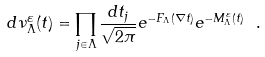Convert formula to latex. <formula><loc_0><loc_0><loc_500><loc_500>d \nu ^ { \varepsilon } _ { \Lambda } ( t ) = \prod _ { j \in \Lambda } \frac { d t _ { j } } { \sqrt { 2 \pi } } e ^ { - F _ { \Lambda } ( \nabla t ) } e ^ { - M ^ { \varepsilon } _ { \Lambda } ( t ) } \ .</formula> 